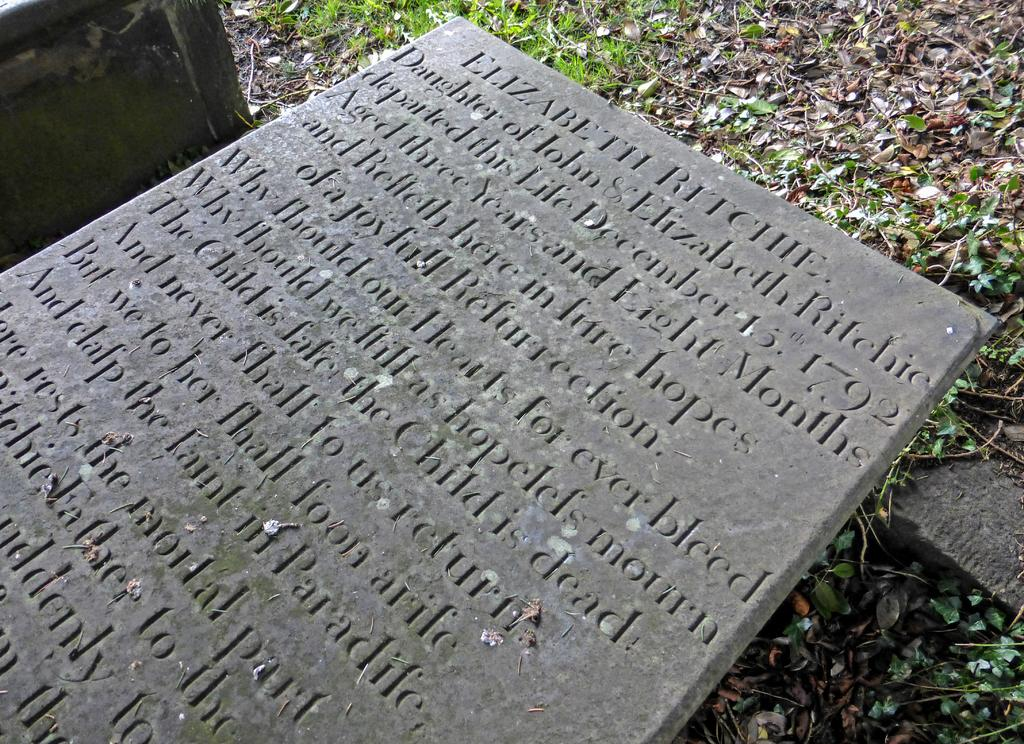What is the main object in the image? There is a concrete block in the image. What is written on the concrete block? There are words written on the concrete block. What type of vegetation can be seen on the ground in the image? There are leaves on the ground in the image. What color is the grass in the image? There is green grass in the image. How does the cow make a decision about which grass to eat in the image? There is no cow present in the image, so it is not possible to answer that question. 